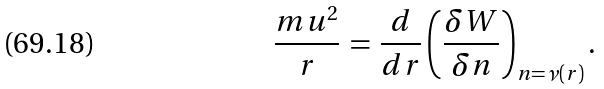Convert formula to latex. <formula><loc_0><loc_0><loc_500><loc_500>\frac { m u ^ { 2 } } { r } \, = \, \frac { d } { d r } \left ( \frac { \delta W } { \delta n } \right ) _ { n = \nu ( r ) } .</formula> 